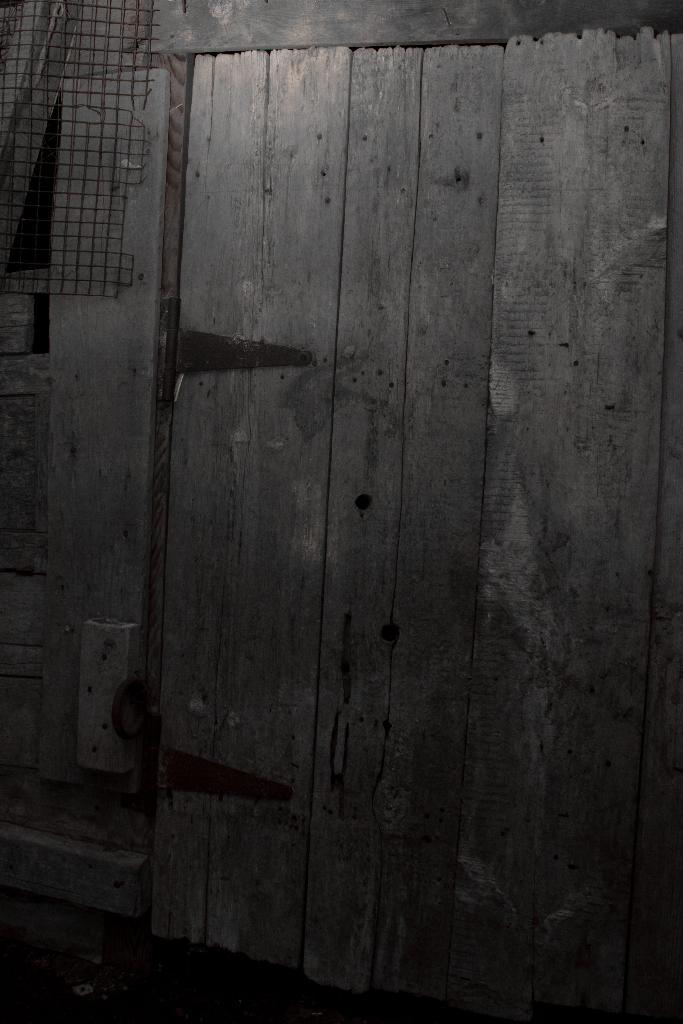What type of door is visible in the image? There is a wooden door in the image. Can you describe the object on the left side of the door? Unfortunately, the provided facts do not give any information about the object on the left side of the door. What type of potato is being served for dinner in the image? There is no dinner or potato present in the image. Is there a boot visible in the image? No, there is no boot visible in the image. 